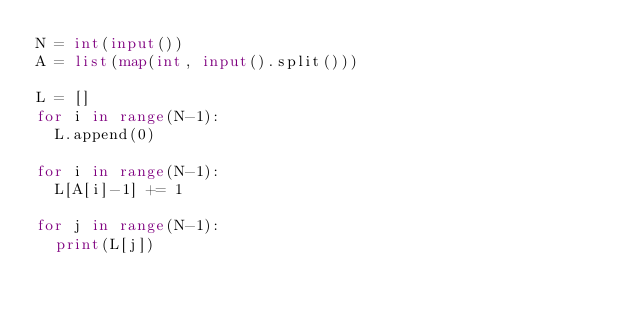Convert code to text. <code><loc_0><loc_0><loc_500><loc_500><_Python_>N = int(input())
A = list(map(int, input().split()))

L = []
for i in range(N-1):
  L.append(0)

for i in range(N-1):
  L[A[i]-1] += 1

for j in range(N-1):
  print(L[j])</code> 